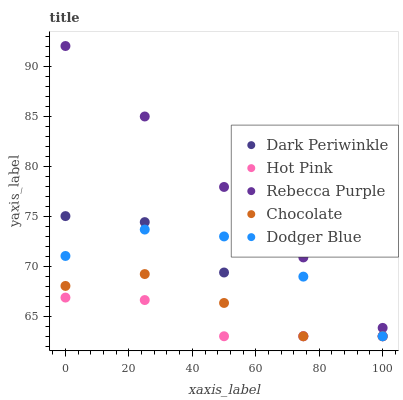Does Hot Pink have the minimum area under the curve?
Answer yes or no. Yes. Does Rebecca Purple have the maximum area under the curve?
Answer yes or no. Yes. Does Dodger Blue have the minimum area under the curve?
Answer yes or no. No. Does Dodger Blue have the maximum area under the curve?
Answer yes or no. No. Is Rebecca Purple the smoothest?
Answer yes or no. Yes. Is Dark Periwinkle the roughest?
Answer yes or no. Yes. Is Hot Pink the smoothest?
Answer yes or no. No. Is Hot Pink the roughest?
Answer yes or no. No. Does Chocolate have the lowest value?
Answer yes or no. Yes. Does Rebecca Purple have the lowest value?
Answer yes or no. No. Does Rebecca Purple have the highest value?
Answer yes or no. Yes. Does Dodger Blue have the highest value?
Answer yes or no. No. Is Chocolate less than Rebecca Purple?
Answer yes or no. Yes. Is Rebecca Purple greater than Dark Periwinkle?
Answer yes or no. Yes. Does Dark Periwinkle intersect Chocolate?
Answer yes or no. Yes. Is Dark Periwinkle less than Chocolate?
Answer yes or no. No. Is Dark Periwinkle greater than Chocolate?
Answer yes or no. No. Does Chocolate intersect Rebecca Purple?
Answer yes or no. No. 